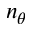Convert formula to latex. <formula><loc_0><loc_0><loc_500><loc_500>n _ { \theta }</formula> 